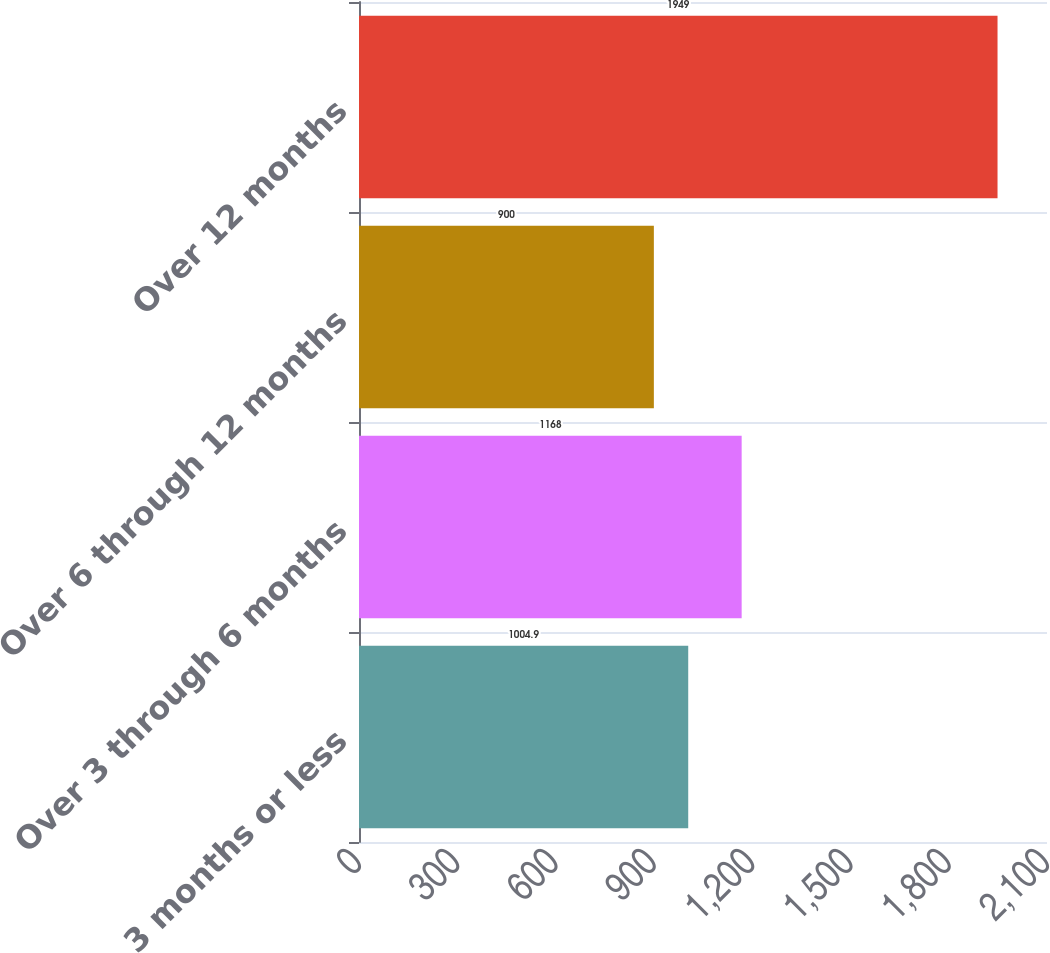Convert chart to OTSL. <chart><loc_0><loc_0><loc_500><loc_500><bar_chart><fcel>3 months or less<fcel>Over 3 through 6 months<fcel>Over 6 through 12 months<fcel>Over 12 months<nl><fcel>1004.9<fcel>1168<fcel>900<fcel>1949<nl></chart> 